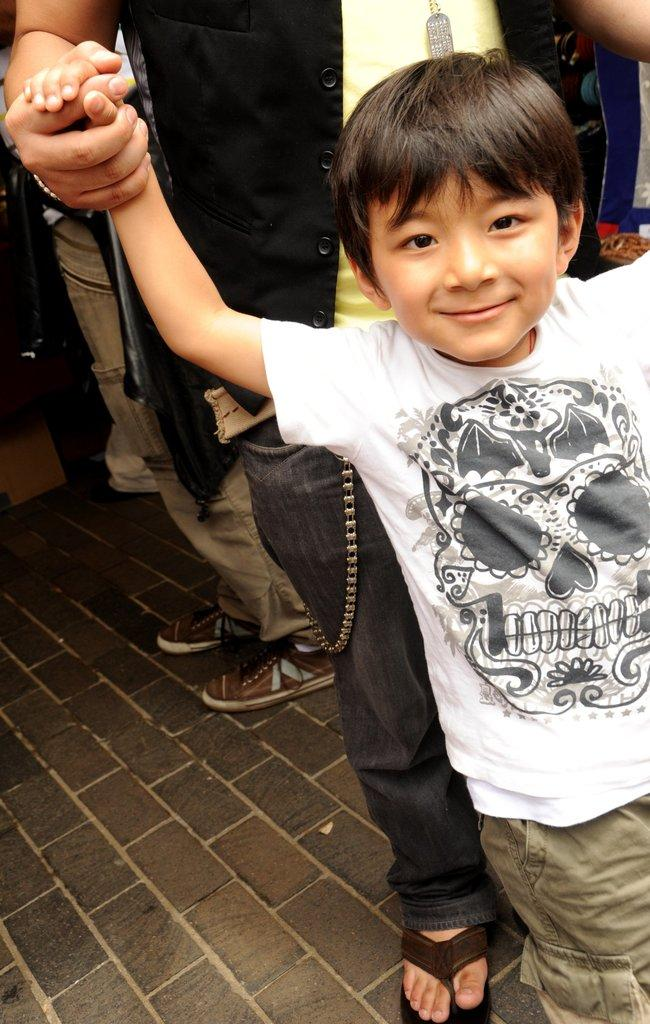Who is the main subject in the foreground of the image? There is a boy standing in the foreground of the image. Is the boy alone in the image? No, there is a person holding the hand of the boy in the image. Can you describe the people visible behind the boy and the person holding his hand? There are other people visible behind the boy and the person holding his hand. What type of soup is the boy eating in the image? There is no soup present in the image; the boy is standing with a person holding his hand. Does the boy in the image express any feelings of hate towards the person holding his hand? There is no indication of any emotions, including hate, in the image; the boy is simply standing with a person holding his hand. 